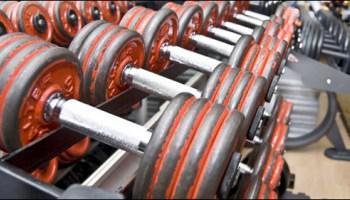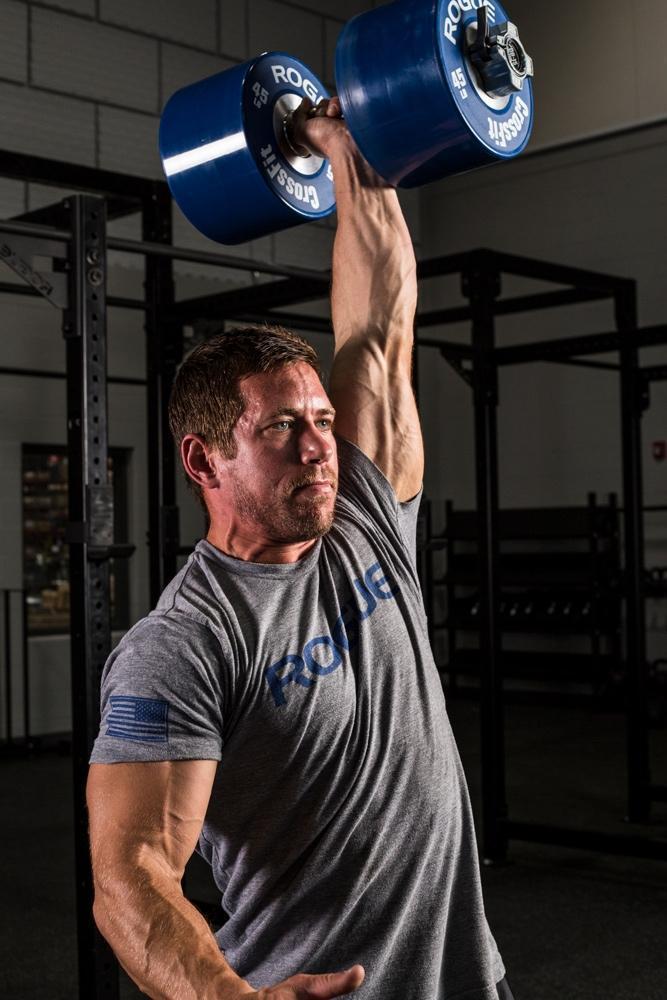The first image is the image on the left, the second image is the image on the right. Considering the images on both sides, is "A weightlifter in one image has one arm stretched straight up, holding a weighted barbell." valid? Answer yes or no. Yes. The first image is the image on the left, the second image is the image on the right. Evaluate the accuracy of this statement regarding the images: "An image shows a forward-facing man lifting a green barbell with the hand on the left of the image.". Is it true? Answer yes or no. No. 